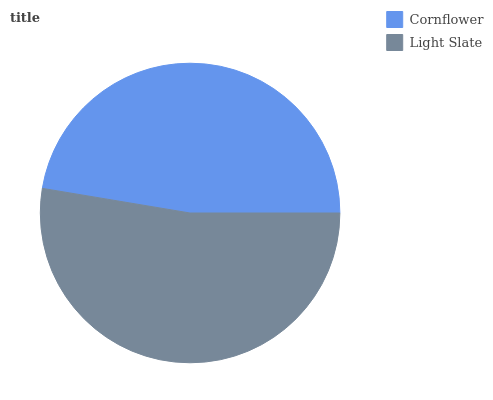Is Cornflower the minimum?
Answer yes or no. Yes. Is Light Slate the maximum?
Answer yes or no. Yes. Is Light Slate the minimum?
Answer yes or no. No. Is Light Slate greater than Cornflower?
Answer yes or no. Yes. Is Cornflower less than Light Slate?
Answer yes or no. Yes. Is Cornflower greater than Light Slate?
Answer yes or no. No. Is Light Slate less than Cornflower?
Answer yes or no. No. Is Light Slate the high median?
Answer yes or no. Yes. Is Cornflower the low median?
Answer yes or no. Yes. Is Cornflower the high median?
Answer yes or no. No. Is Light Slate the low median?
Answer yes or no. No. 